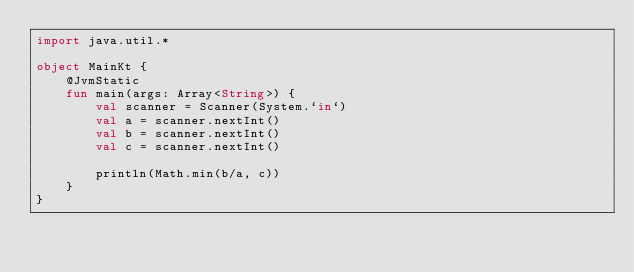Convert code to text. <code><loc_0><loc_0><loc_500><loc_500><_Kotlin_>import java.util.*

object MainKt {
	@JvmStatic
	fun main(args: Array<String>) {
		val scanner = Scanner(System.`in`)
		val a = scanner.nextInt()
		val b = scanner.nextInt()
		val c = scanner.nextInt()

		println(Math.min(b/a, c))
	}
}</code> 